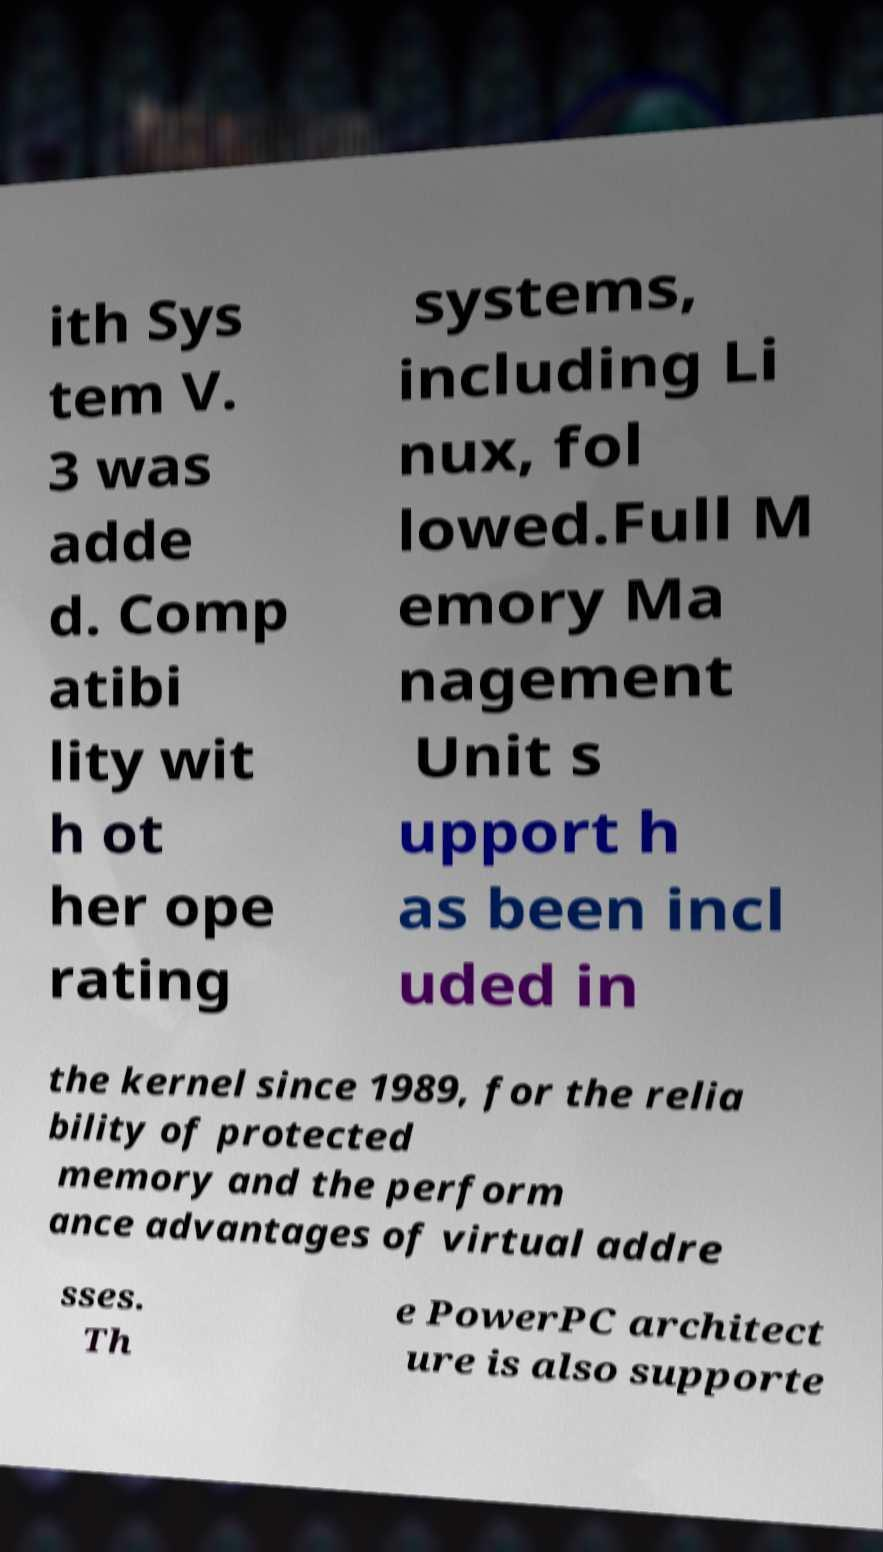Could you extract and type out the text from this image? ith Sys tem V. 3 was adde d. Comp atibi lity wit h ot her ope rating systems, including Li nux, fol lowed.Full M emory Ma nagement Unit s upport h as been incl uded in the kernel since 1989, for the relia bility of protected memory and the perform ance advantages of virtual addre sses. Th e PowerPC architect ure is also supporte 